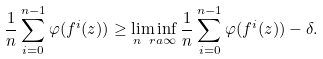<formula> <loc_0><loc_0><loc_500><loc_500>\frac { 1 } { n } \sum _ { i = 0 } ^ { n - 1 } \varphi ( f ^ { i } ( z ) ) \geq \liminf _ { n \ r a \infty } \frac { 1 } { n } \sum _ { i = 0 } ^ { n - 1 } \varphi ( f ^ { i } ( z ) ) - \delta .</formula> 